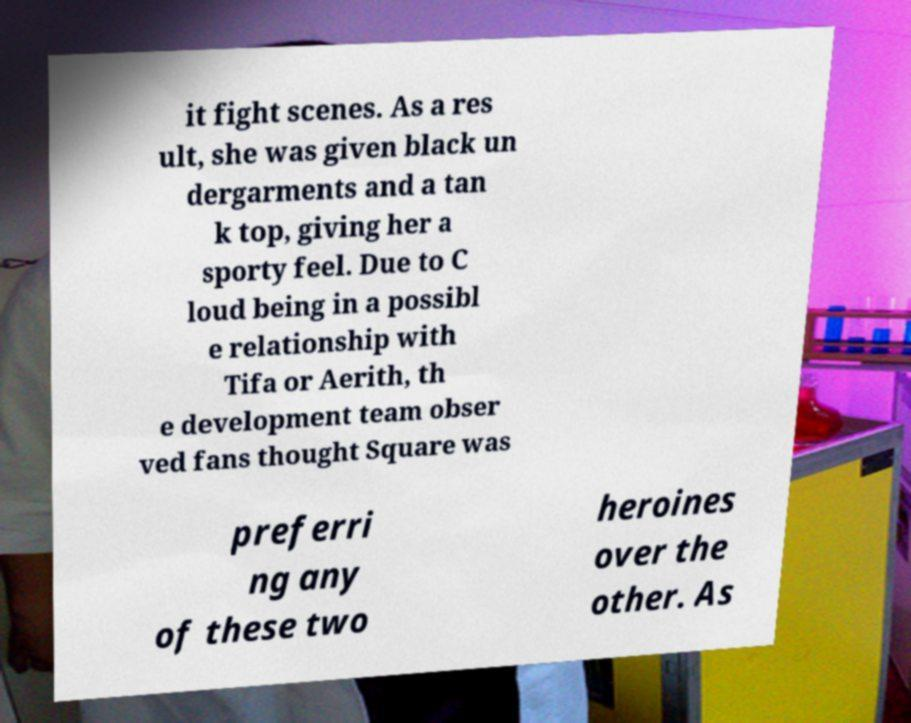Could you assist in decoding the text presented in this image and type it out clearly? it fight scenes. As a res ult, she was given black un dergarments and a tan k top, giving her a sporty feel. Due to C loud being in a possibl e relationship with Tifa or Aerith, th e development team obser ved fans thought Square was preferri ng any of these two heroines over the other. As 